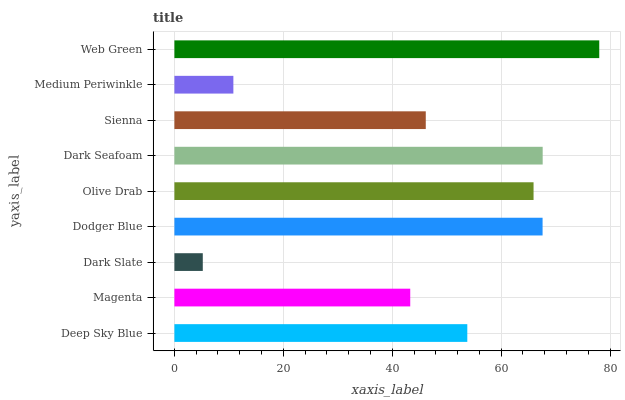Is Dark Slate the minimum?
Answer yes or no. Yes. Is Web Green the maximum?
Answer yes or no. Yes. Is Magenta the minimum?
Answer yes or no. No. Is Magenta the maximum?
Answer yes or no. No. Is Deep Sky Blue greater than Magenta?
Answer yes or no. Yes. Is Magenta less than Deep Sky Blue?
Answer yes or no. Yes. Is Magenta greater than Deep Sky Blue?
Answer yes or no. No. Is Deep Sky Blue less than Magenta?
Answer yes or no. No. Is Deep Sky Blue the high median?
Answer yes or no. Yes. Is Deep Sky Blue the low median?
Answer yes or no. Yes. Is Olive Drab the high median?
Answer yes or no. No. Is Olive Drab the low median?
Answer yes or no. No. 